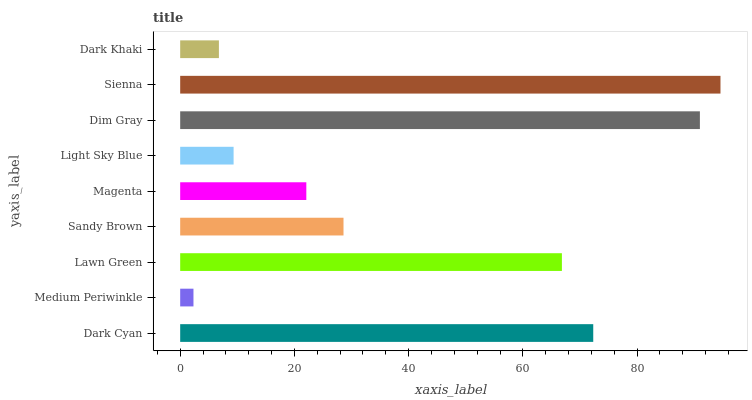Is Medium Periwinkle the minimum?
Answer yes or no. Yes. Is Sienna the maximum?
Answer yes or no. Yes. Is Lawn Green the minimum?
Answer yes or no. No. Is Lawn Green the maximum?
Answer yes or no. No. Is Lawn Green greater than Medium Periwinkle?
Answer yes or no. Yes. Is Medium Periwinkle less than Lawn Green?
Answer yes or no. Yes. Is Medium Periwinkle greater than Lawn Green?
Answer yes or no. No. Is Lawn Green less than Medium Periwinkle?
Answer yes or no. No. Is Sandy Brown the high median?
Answer yes or no. Yes. Is Sandy Brown the low median?
Answer yes or no. Yes. Is Dark Khaki the high median?
Answer yes or no. No. Is Light Sky Blue the low median?
Answer yes or no. No. 